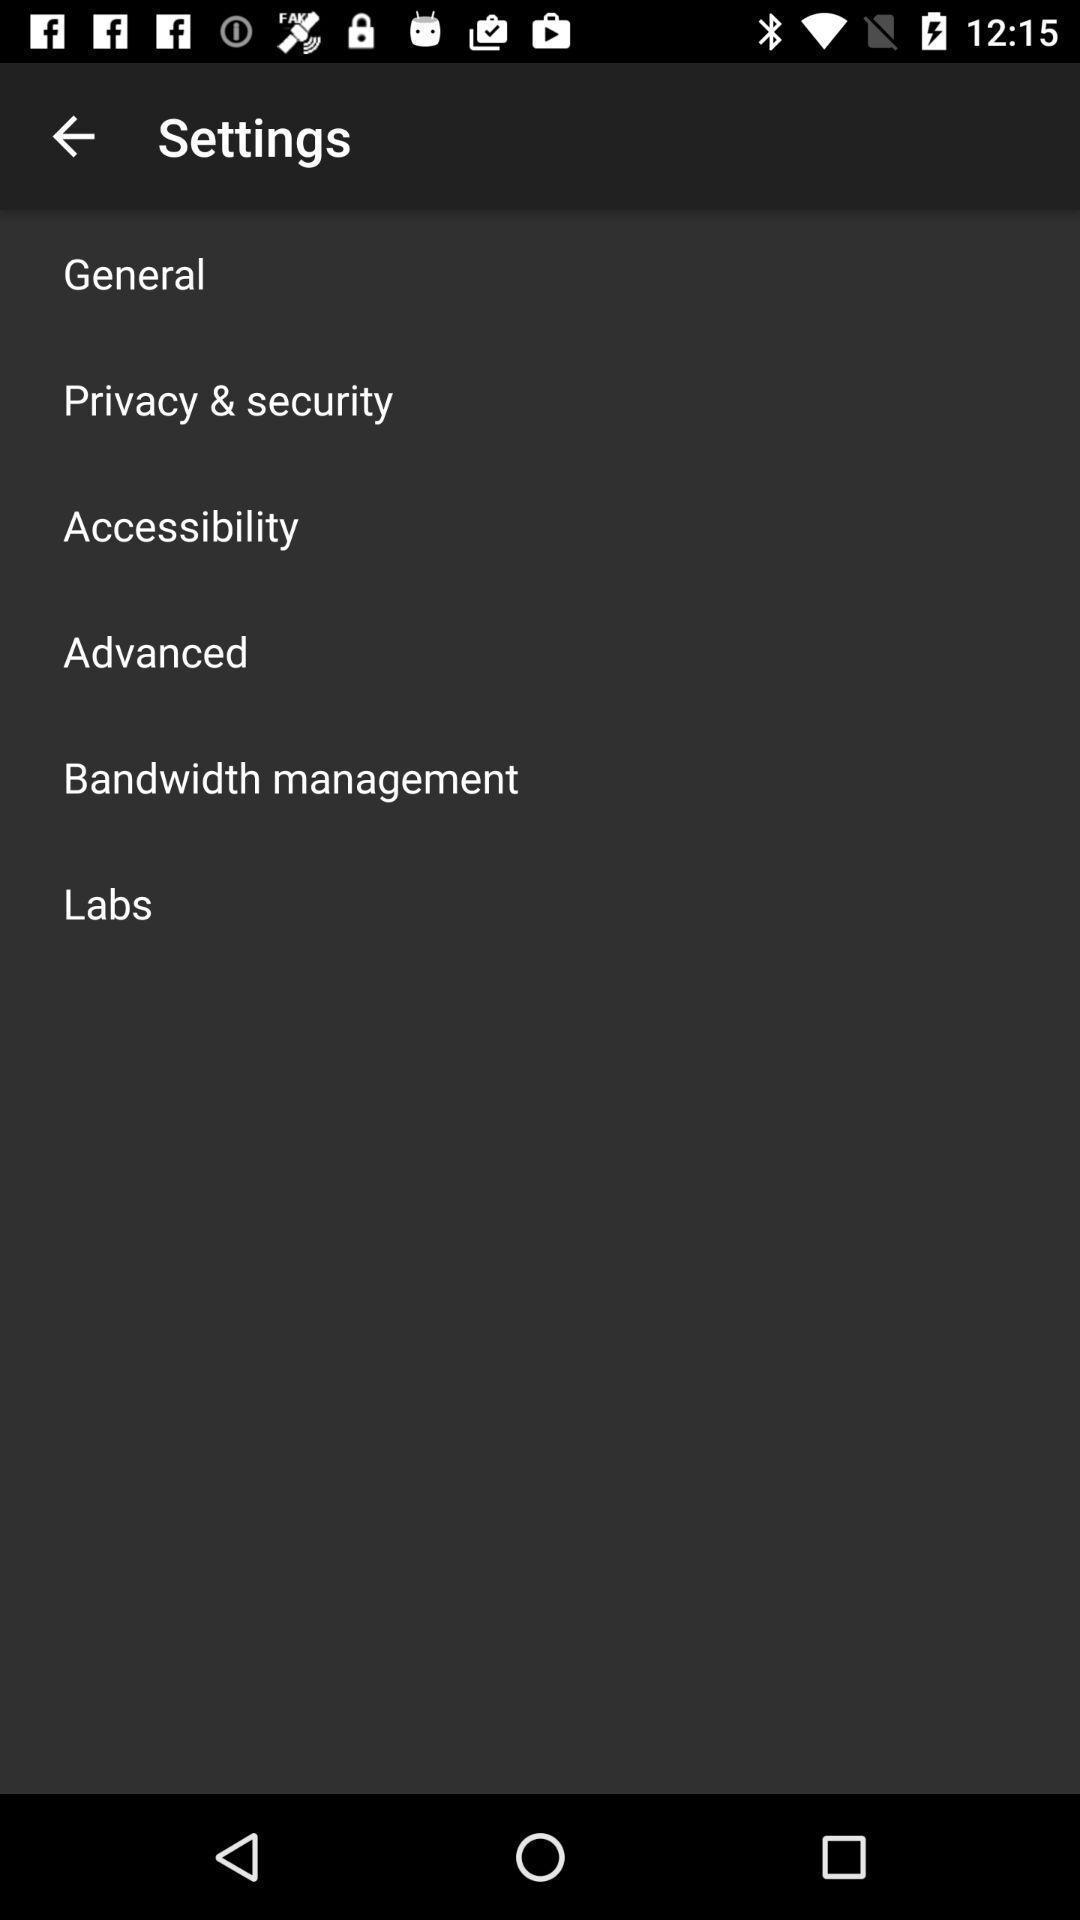Tell me what you see in this picture. Setting page displaying various options. 